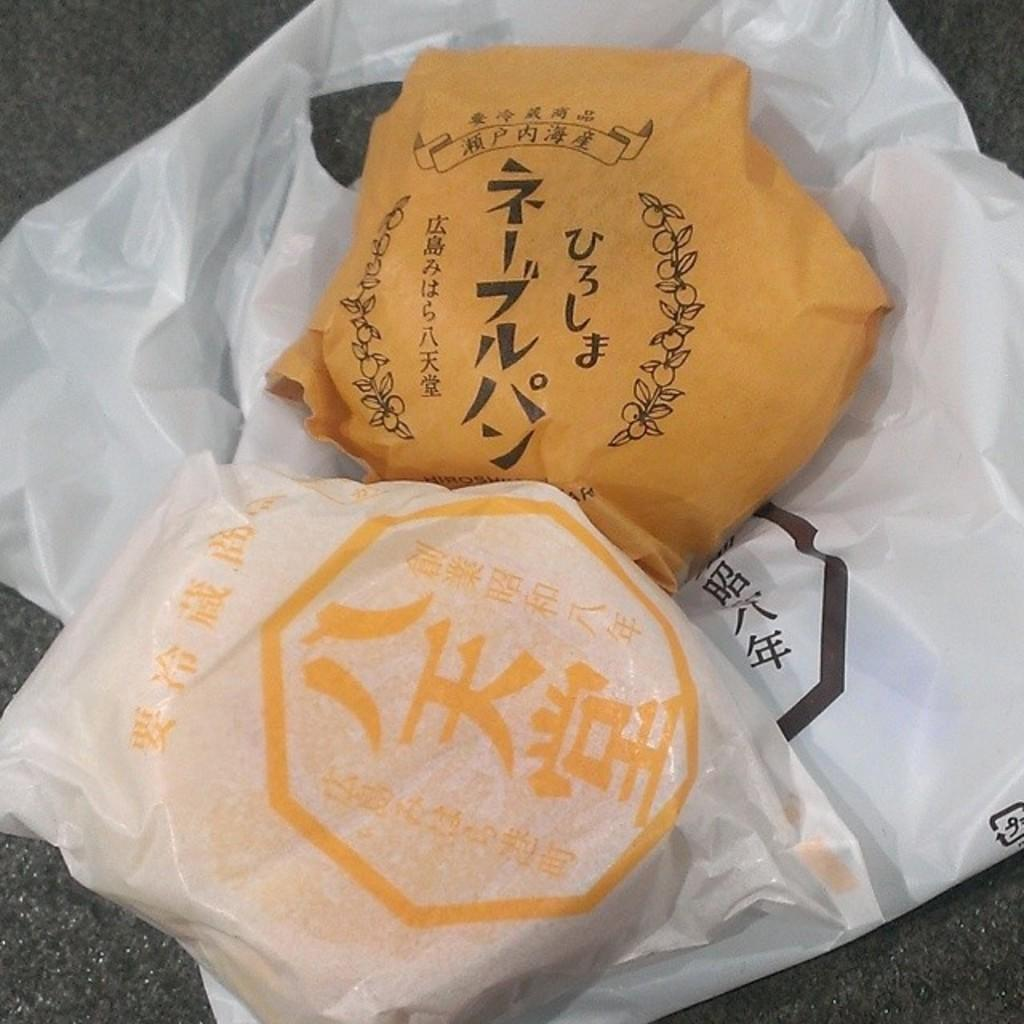What is the main piece of furniture in the image? There is a table in the image. What is covering the table? The table has a cover. What type of food can be seen on the table? There are two burgers on the table. What is the name of the baby born in the image? There is no baby or birth depicted in the image; it features a table with a cover and two burgers. Is there a spy present in the image? There is no indication of a spy or any espionage activity in the image. 